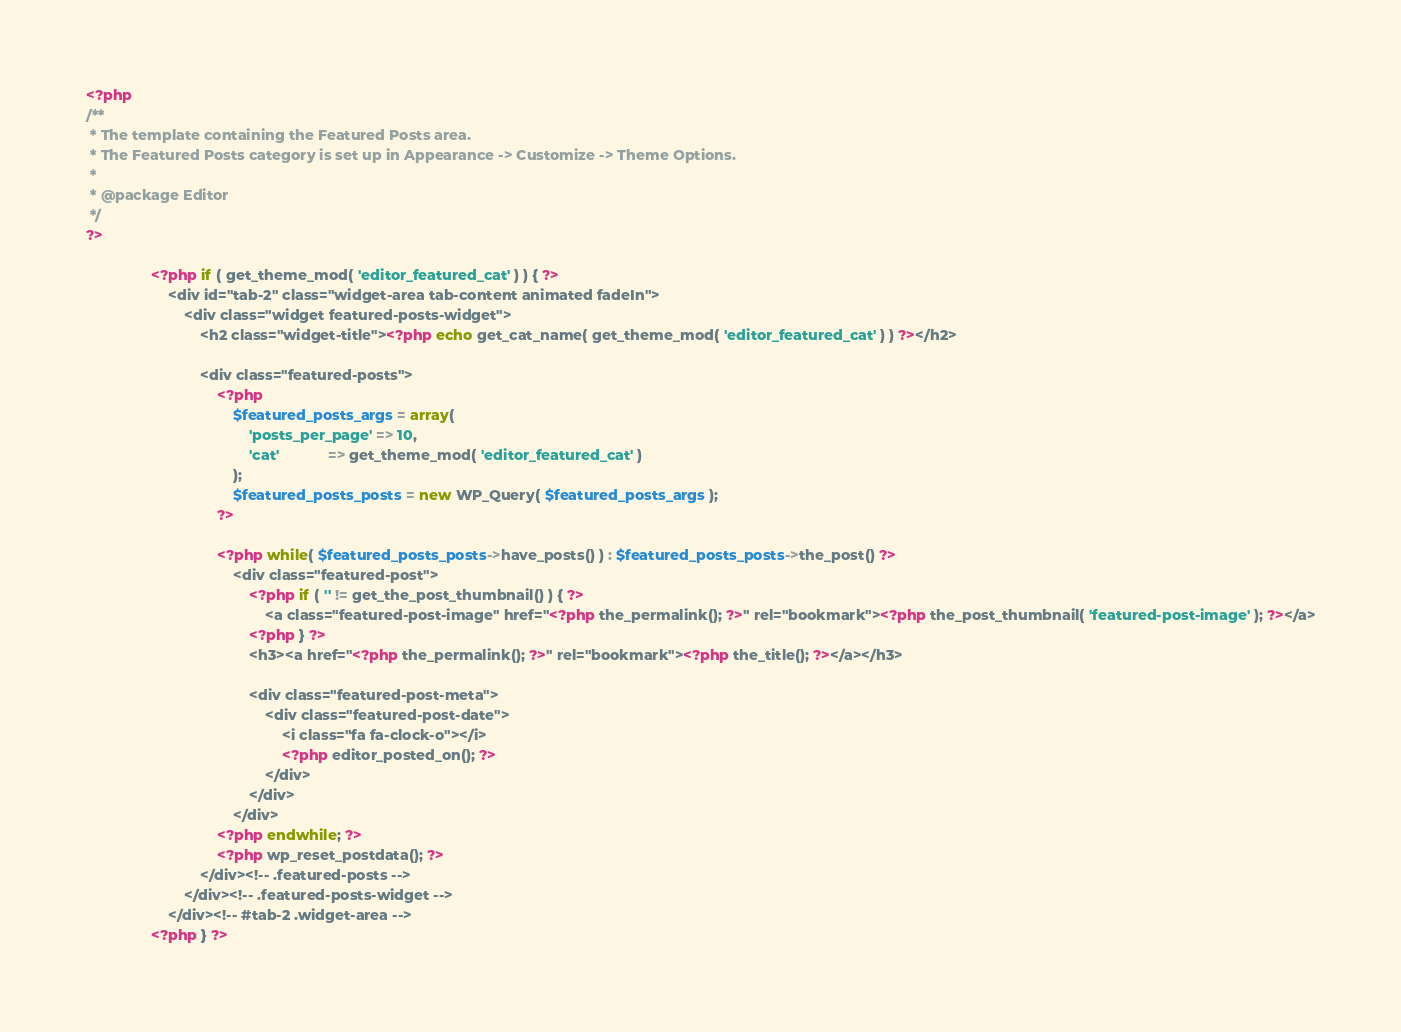Convert code to text. <code><loc_0><loc_0><loc_500><loc_500><_PHP_><?php
/**
 * The template containing the Featured Posts area.
 * The Featured Posts category is set up in Appearance -> Customize -> Theme Options.
 *
 * @package Editor
 */
?>

				<?php if ( get_theme_mod( 'editor_featured_cat' ) ) { ?>
					<div id="tab-2" class="widget-area tab-content animated fadeIn">
						<div class="widget featured-posts-widget">
							<h2 class="widget-title"><?php echo get_cat_name( get_theme_mod( 'editor_featured_cat' ) ) ?></h2>

							<div class="featured-posts">
							    <?php
									$featured_posts_args = array(
										'posts_per_page' => 10,
										'cat'            => get_theme_mod( 'editor_featured_cat' )
									);
									$featured_posts_posts = new WP_Query( $featured_posts_args );
								?>

								<?php while( $featured_posts_posts->have_posts() ) : $featured_posts_posts->the_post() ?>
									<div class="featured-post">
										<?php if ( '' != get_the_post_thumbnail() ) { ?>
							            	<a class="featured-post-image" href="<?php the_permalink(); ?>" rel="bookmark"><?php the_post_thumbnail( 'featured-post-image' ); ?></a>
							            <?php } ?>
							            <h3><a href="<?php the_permalink(); ?>" rel="bookmark"><?php the_title(); ?></a></h3>

							            <div class="featured-post-meta">
								            <div class="featured-post-date">
								            	<i class="fa fa-clock-o"></i>
								            	<?php editor_posted_on(); ?>
								            </div>
							            </div>
									</div>
								<?php endwhile; ?>
								<?php wp_reset_postdata(); ?>
							</div><!-- .featured-posts -->
						</div><!-- .featured-posts-widget -->
					</div><!-- #tab-2 .widget-area -->
				<?php } ?></code> 